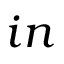<formula> <loc_0><loc_0><loc_500><loc_500>i n</formula> 